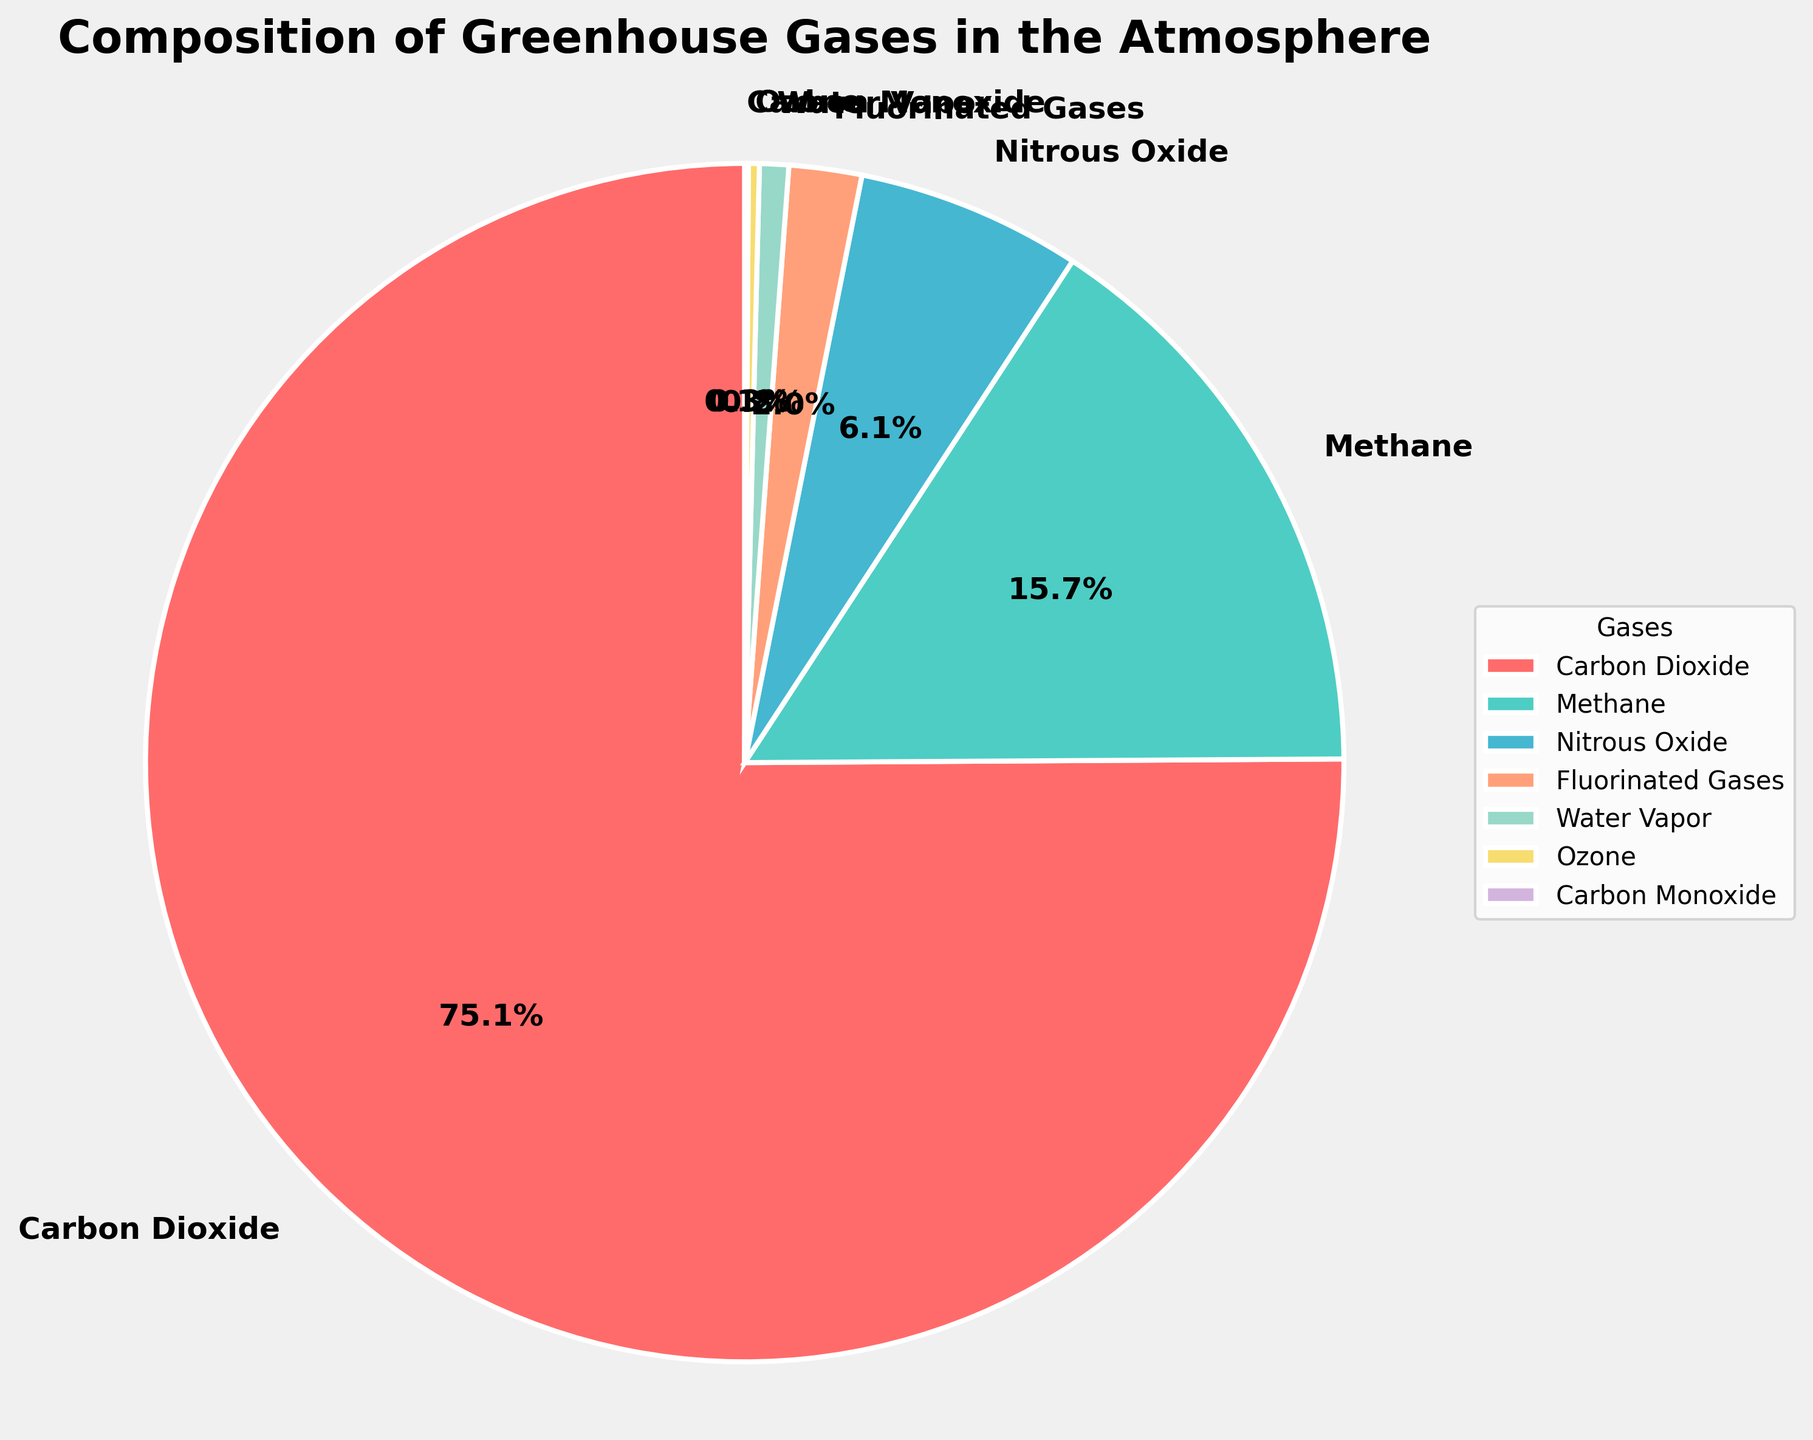What's the total percentage of Carbon Dioxide and Methane in the atmosphere? To find the total percentage of Carbon Dioxide and Methane combined, sum their individual percentages. From the pie chart, Carbon Dioxide is 76.6% and Methane is 16.0%. So, 76.6 + 16.0 = 92.6.
Answer: 92.6 Which gas has the smallest percentage in the atmosphere? Examine the pie chart to identify the gas with the smallest slice. From the data, Carbon Monoxide has the smallest slice.
Answer: Carbon Monoxide How much greater is the percentage of Nitrous Oxide compared to Water Vapor? Find the difference between the percentages of Nitrous Oxide and Water Vapor. From the pie chart, Nitrous Oxide is 6.2% and Water Vapor is 0.8%. So, 6.2 - 0.8 = 5.4.
Answer: 5.4 Which gases combined make up less than 10% of the total greenhouse gases? Identify the gases with individual percentages less than 10% and sum them. From the pie chart, the relevant gases are Nitrous Oxide (6.2%), Fluorinated Gases (2.0%), Water Vapor (0.8%), Ozone (0.3%), and Carbon Monoxide (0.1%). Their combined percentage is 6.2 + 2.0 + 0.8 + 0.3 + 0.1 = 9.4, which is less than 10%.
Answer: Nitrous Oxide, Fluorinated Gases, Water Vapor, Ozone, Carbon Monoxide What color represents Methane in the pie chart? Observe the pie chart to identify the color associated with Methane. Methane is represented by the teal color.
Answer: Teal Rank the gases from highest to lowest percentage. Order the gases by their percentages as shown in the pie chart. From highest to lowest: Carbon Dioxide (76.6%), Methane (16.0%), Nitrous Oxide (6.2%), Fluorinated Gases (2.0%), Water Vapor (0.8%), Ozone (0.3%), Carbon Monoxide (0.1%).
Answer: Carbon Dioxide, Methane, Nitrous Oxide, Fluorinated Gases, Water Vapor, Ozone, Carbon Monoxide What's the percentage difference between Carbon Dioxide and the combined percentage of Fluorinated Gases, Water Vapor, Ozone, and Carbon Monoxide? Find the difference between Carbon Dioxide's percentage and the sum of the percentages of Fluorinated Gases, Water Vapor, Ozone, and Carbon Monoxide. Carbon Dioxide is 76.6%. The sum of the other four gases is 2.0 + 0.8 + 0.3 + 0.1 = 3.2%. Therefore, 76.6 - 3.2 = 73.4%.
Answer: 73.4 